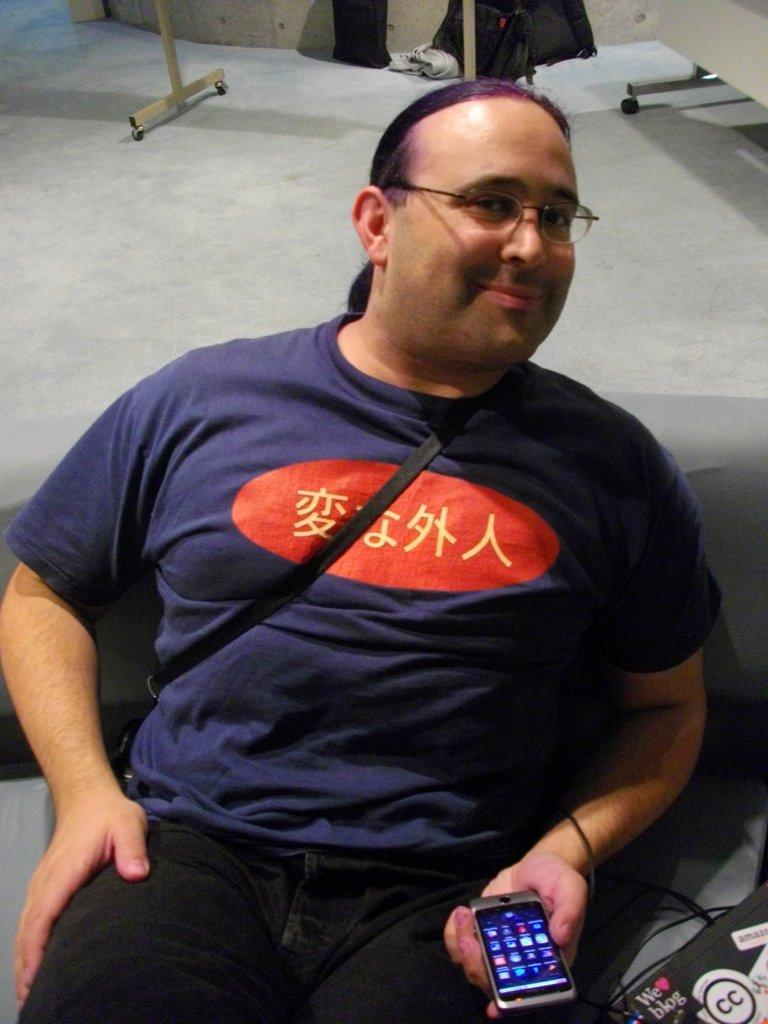What is the main subject of the image? There is a man in the image. What is the man doing in the image? The man is sitting. What object is the man holding in his hand? The man is holding a mobile with his hand. What color is the friend of the man in the image? There is no friend present in the image, so it is not possible to determine the color of their clothing or appearance. 